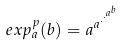<formula> <loc_0><loc_0><loc_500><loc_500>e x p _ { a } ^ { p } ( b ) = a ^ { a ^ { \cdot ^ { \cdot ^ { a ^ { b } } } } }</formula> 